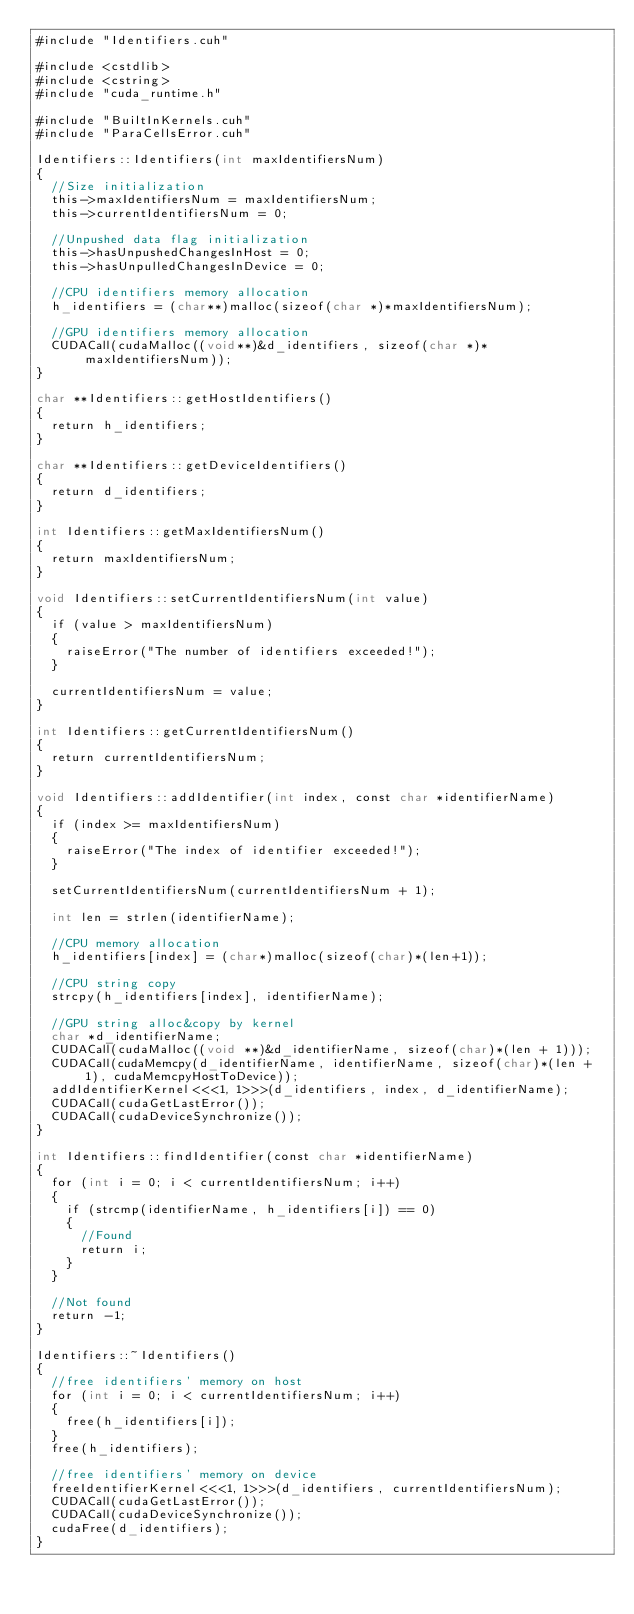<code> <loc_0><loc_0><loc_500><loc_500><_Cuda_>#include "Identifiers.cuh"

#include <cstdlib>
#include <cstring>
#include "cuda_runtime.h"

#include "BuiltInKernels.cuh"
#include "ParaCellsError.cuh"

Identifiers::Identifiers(int maxIdentifiersNum)
{
	//Size initialization
	this->maxIdentifiersNum = maxIdentifiersNum;
	this->currentIdentifiersNum = 0;

	//Unpushed data flag initialization
	this->hasUnpushedChangesInHost = 0;
	this->hasUnpulledChangesInDevice = 0;

	//CPU identifiers memory allocation
	h_identifiers = (char**)malloc(sizeof(char *)*maxIdentifiersNum);

	//GPU identifiers memory allocation
	CUDACall(cudaMalloc((void**)&d_identifiers, sizeof(char *)*maxIdentifiersNum));
}

char **Identifiers::getHostIdentifiers()
{
	return h_identifiers;
}

char **Identifiers::getDeviceIdentifiers()
{
	return d_identifiers;
}

int Identifiers::getMaxIdentifiersNum()
{
	return maxIdentifiersNum;
}

void Identifiers::setCurrentIdentifiersNum(int value)
{
	if (value > maxIdentifiersNum)
	{
		raiseError("The number of identifiers exceeded!");
	}

	currentIdentifiersNum = value;
}

int Identifiers::getCurrentIdentifiersNum()
{
	return currentIdentifiersNum;
}

void Identifiers::addIdentifier(int index, const char *identifierName)
{
	if (index >= maxIdentifiersNum)
	{
		raiseError("The index of identifier exceeded!");
	}

	setCurrentIdentifiersNum(currentIdentifiersNum + 1);

	int len = strlen(identifierName);

	//CPU memory allocation
	h_identifiers[index] = (char*)malloc(sizeof(char)*(len+1));

	//CPU string copy
	strcpy(h_identifiers[index], identifierName);

	//GPU string alloc&copy by kernel
	char *d_identifierName;
	CUDACall(cudaMalloc((void **)&d_identifierName, sizeof(char)*(len + 1)));
	CUDACall(cudaMemcpy(d_identifierName, identifierName, sizeof(char)*(len + 1), cudaMemcpyHostToDevice));
	addIdentifierKernel<<<1, 1>>>(d_identifiers, index, d_identifierName);
	CUDACall(cudaGetLastError());
	CUDACall(cudaDeviceSynchronize());
}

int Identifiers::findIdentifier(const char *identifierName)
{
	for (int i = 0; i < currentIdentifiersNum; i++)
	{
		if (strcmp(identifierName, h_identifiers[i]) == 0)
		{
			//Found
			return i;
		}
	}

	//Not found
	return -1;
}

Identifiers::~Identifiers()
{
	//free identifiers' memory on host
	for (int i = 0; i < currentIdentifiersNum; i++)
	{
		free(h_identifiers[i]);
	}
	free(h_identifiers);

	//free identifiers' memory on device
	freeIdentifierKernel<<<1, 1>>>(d_identifiers, currentIdentifiersNum);
	CUDACall(cudaGetLastError());
	CUDACall(cudaDeviceSynchronize());
	cudaFree(d_identifiers);
}</code> 